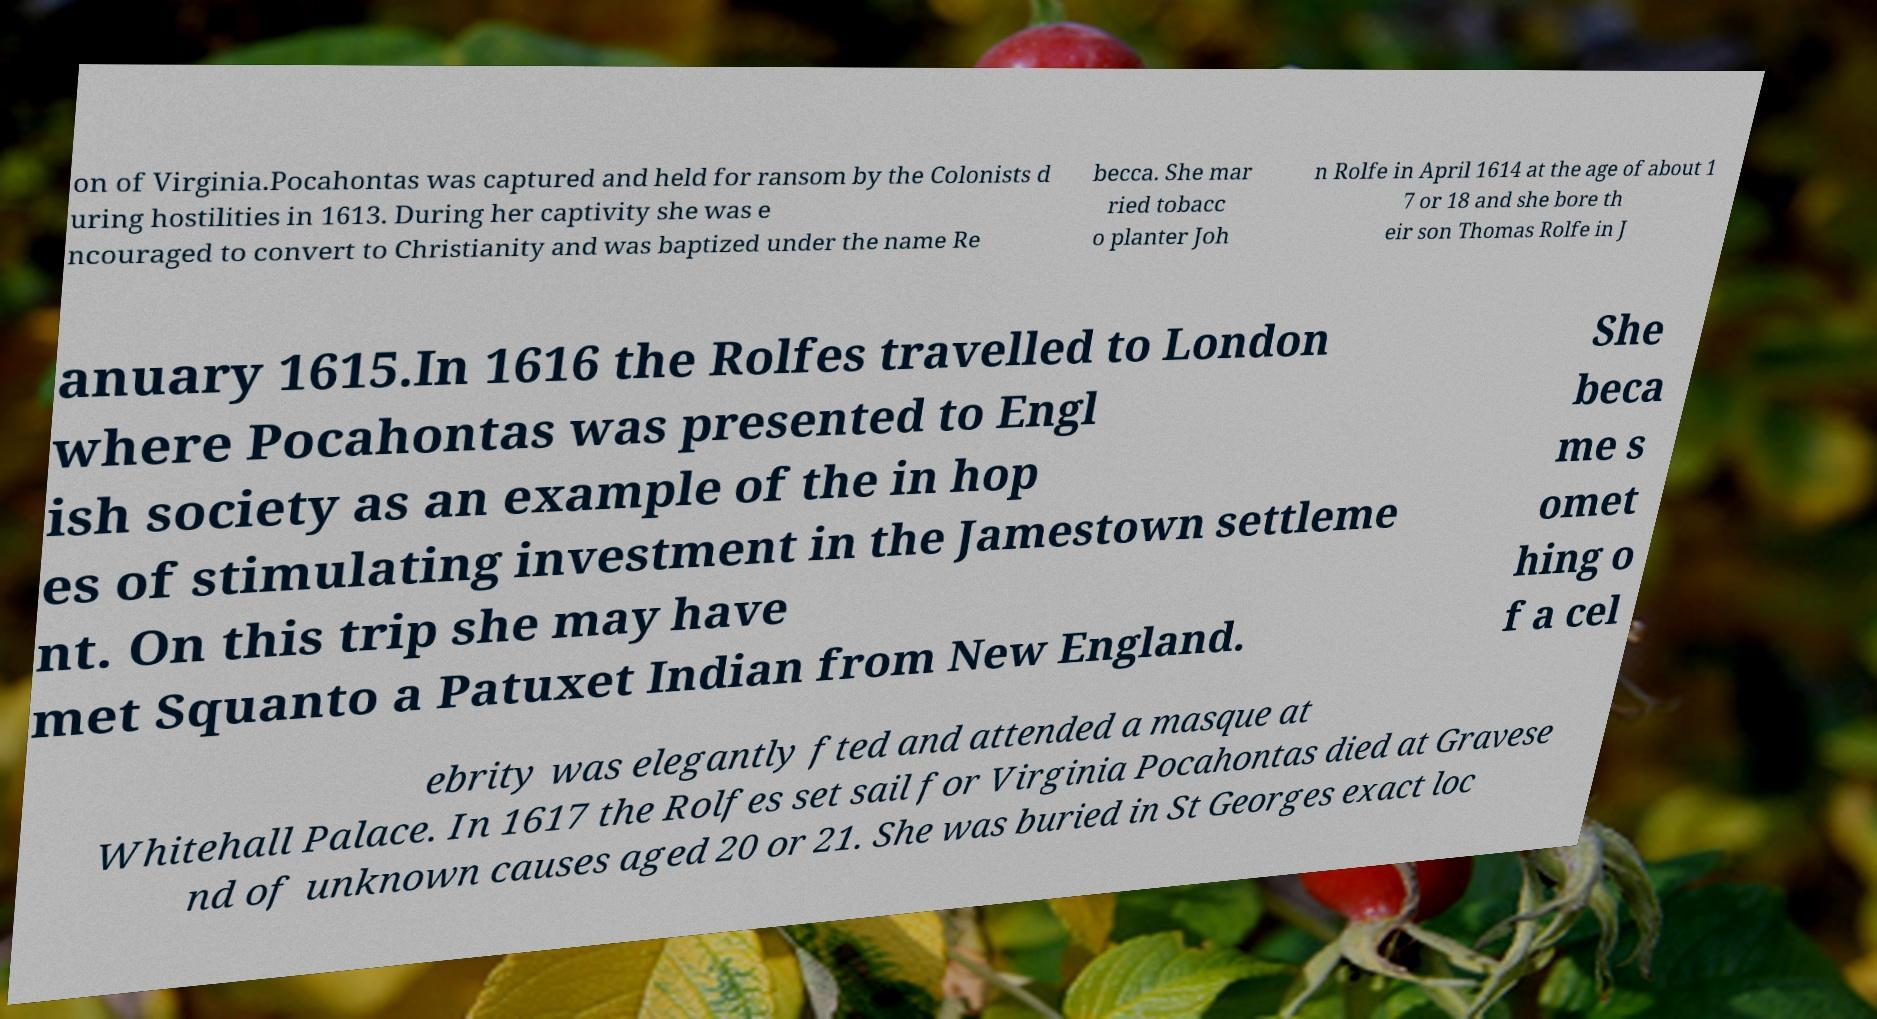Could you assist in decoding the text presented in this image and type it out clearly? on of Virginia.Pocahontas was captured and held for ransom by the Colonists d uring hostilities in 1613. During her captivity she was e ncouraged to convert to Christianity and was baptized under the name Re becca. She mar ried tobacc o planter Joh n Rolfe in April 1614 at the age of about 1 7 or 18 and she bore th eir son Thomas Rolfe in J anuary 1615.In 1616 the Rolfes travelled to London where Pocahontas was presented to Engl ish society as an example of the in hop es of stimulating investment in the Jamestown settleme nt. On this trip she may have met Squanto a Patuxet Indian from New England. She beca me s omet hing o f a cel ebrity was elegantly fted and attended a masque at Whitehall Palace. In 1617 the Rolfes set sail for Virginia Pocahontas died at Gravese nd of unknown causes aged 20 or 21. She was buried in St Georges exact loc 